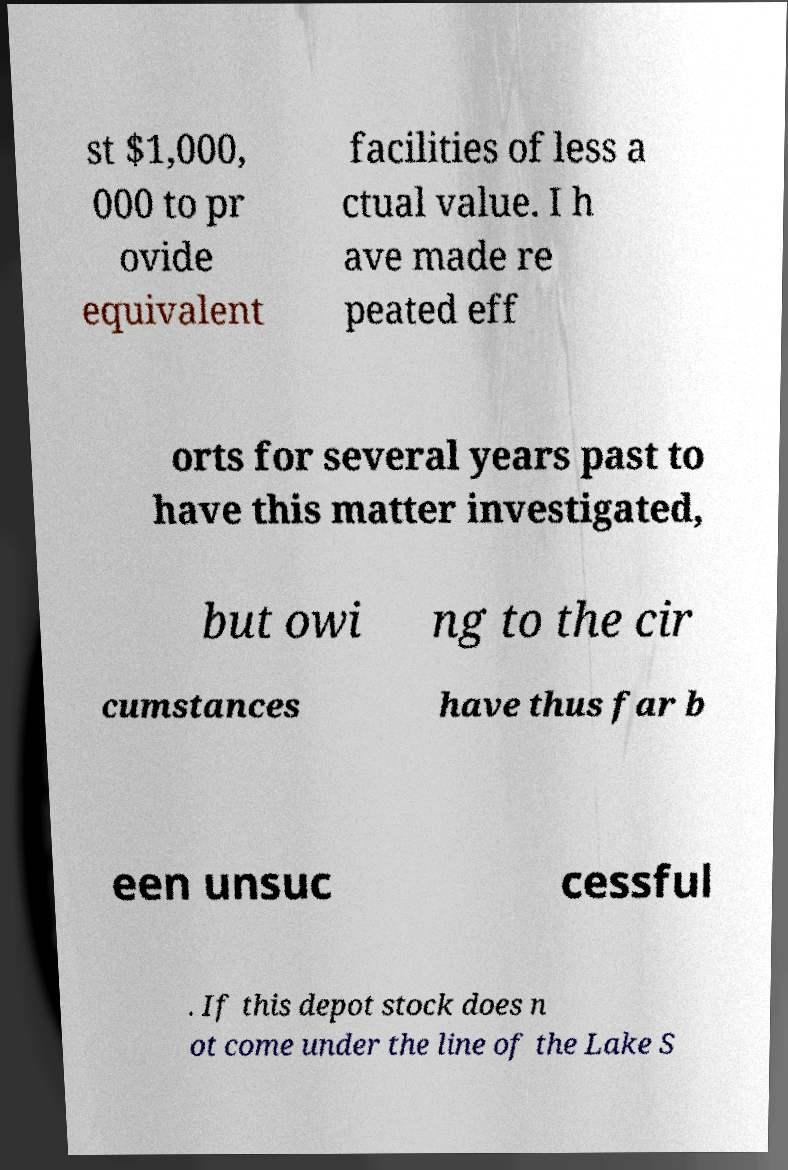Can you read and provide the text displayed in the image?This photo seems to have some interesting text. Can you extract and type it out for me? st $1,000, 000 to pr ovide equivalent facilities of less a ctual value. I h ave made re peated eff orts for several years past to have this matter investigated, but owi ng to the cir cumstances have thus far b een unsuc cessful . If this depot stock does n ot come under the line of the Lake S 